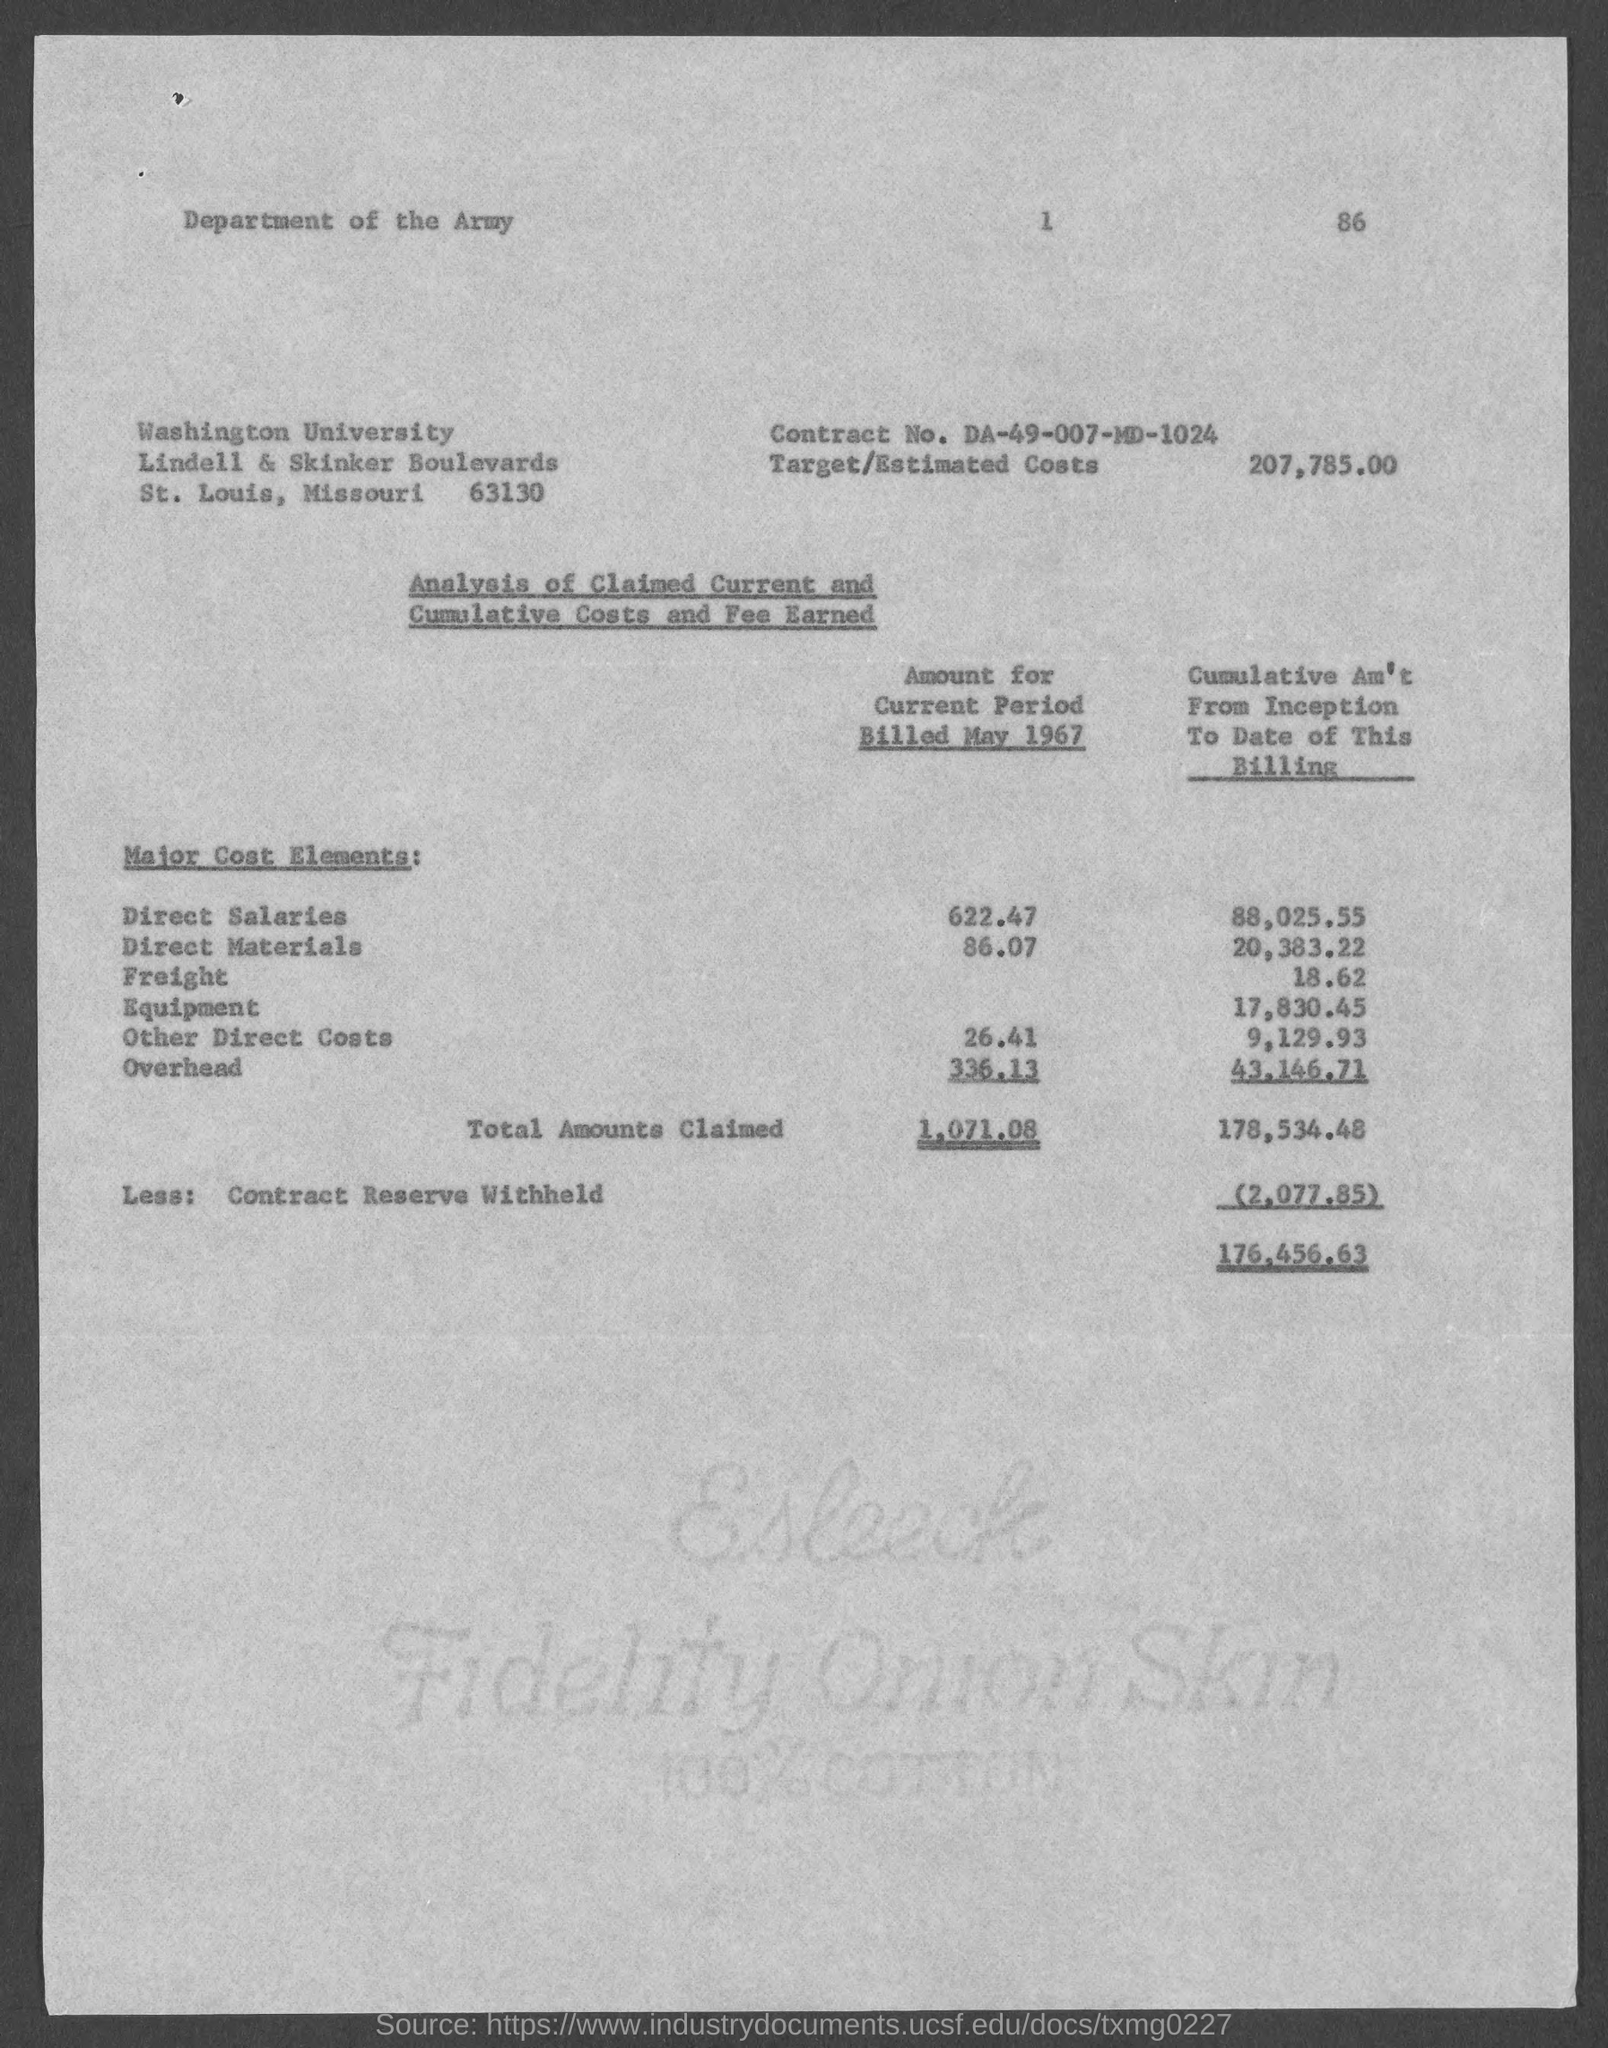In which state is washington university at?
Offer a terse response. Missouri. What is the contract no.?
Your answer should be compact. DA-49-007-MD-1024. What is the target/estimated costs ?
Your answer should be compact. 207,785.00. What is the amount for current period billed may 1967 for direct salaries ?
Ensure brevity in your answer.  622.47. What is the amount for current period billed may 1967 for direct materials ?
Provide a succinct answer. 86.07. What is the amount for current period billed may 1967 for other direct costs?
Offer a very short reply. 26.41. What is the amount for current period billed may 1967 for overhead?
Provide a short and direct response. 336.13. 